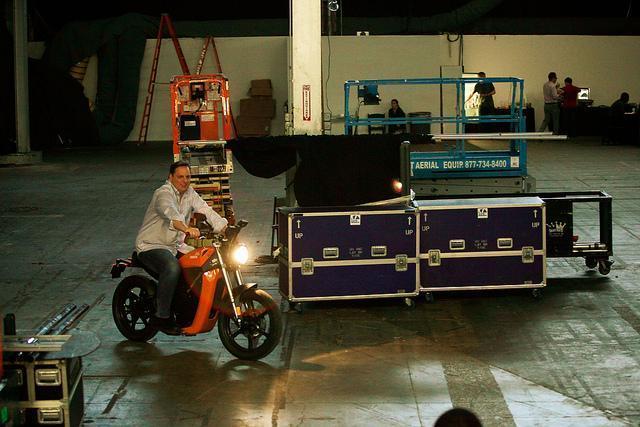How many people are in the background?
Give a very brief answer. 5. How many trunks are near the man?
Give a very brief answer. 2. How many people are wearing blue?
Give a very brief answer. 0. 